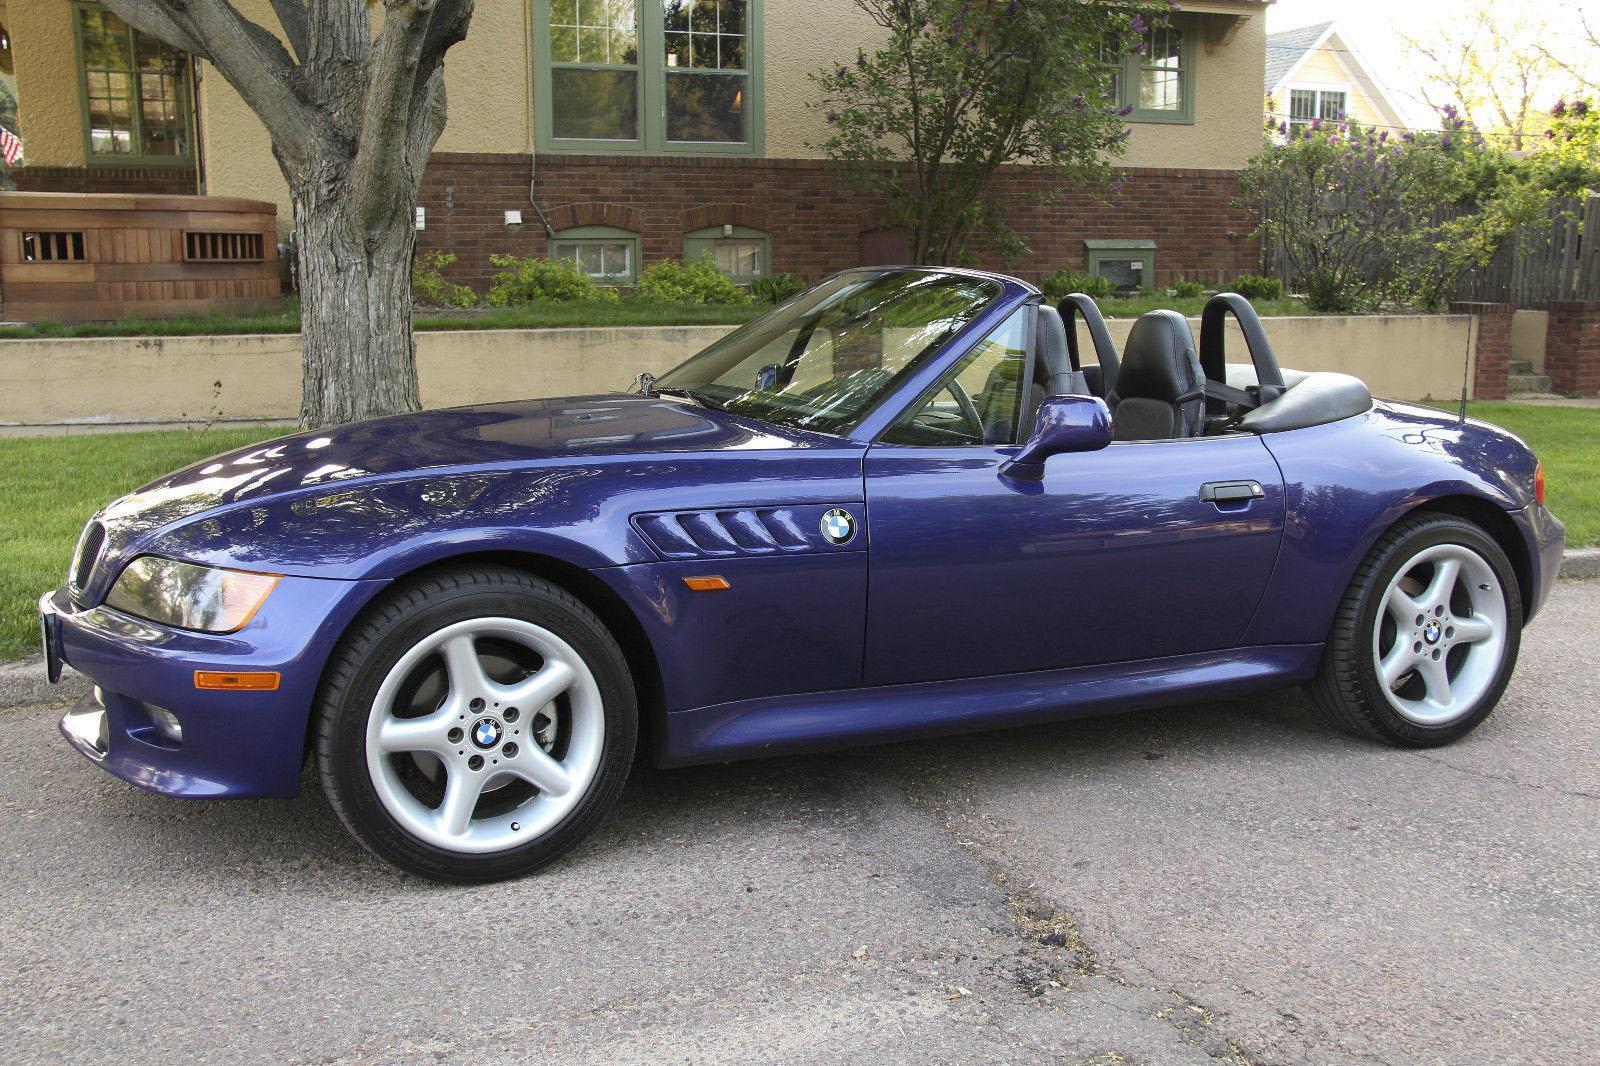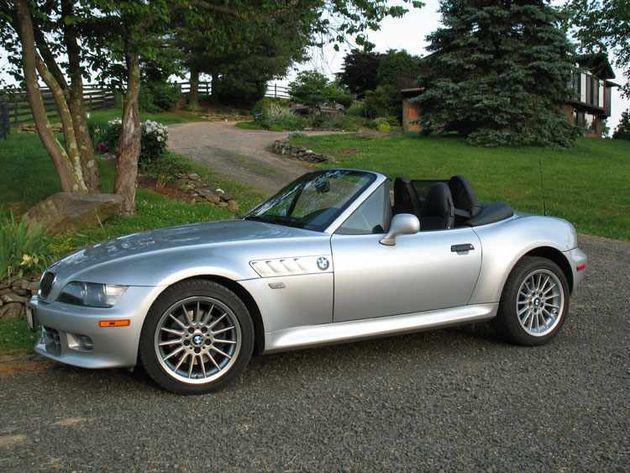The first image is the image on the left, the second image is the image on the right. Analyze the images presented: Is the assertion "There is 1 or more silver cars on the road." valid? Answer yes or no. Yes. The first image is the image on the left, the second image is the image on the right. Analyze the images presented: Is the assertion "there is a car parked on the street in front of a house" valid? Answer yes or no. Yes. 